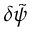<formula> <loc_0><loc_0><loc_500><loc_500>\delta \tilde { \psi }</formula> 